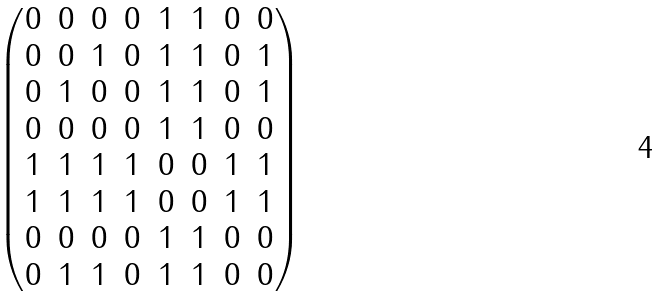<formula> <loc_0><loc_0><loc_500><loc_500>\begin{pmatrix} 0 & 0 & 0 & 0 & 1 & 1 & 0 & 0 \\ 0 & 0 & 1 & 0 & 1 & 1 & 0 & 1 \\ 0 & 1 & 0 & 0 & 1 & 1 & 0 & 1 \\ 0 & 0 & 0 & 0 & 1 & 1 & 0 & 0 \\ 1 & 1 & 1 & 1 & 0 & 0 & 1 & 1 \\ 1 & 1 & 1 & 1 & 0 & 0 & 1 & 1 \\ 0 & 0 & 0 & 0 & 1 & 1 & 0 & 0 \\ 0 & 1 & 1 & 0 & 1 & 1 & 0 & 0 \end{pmatrix}</formula> 